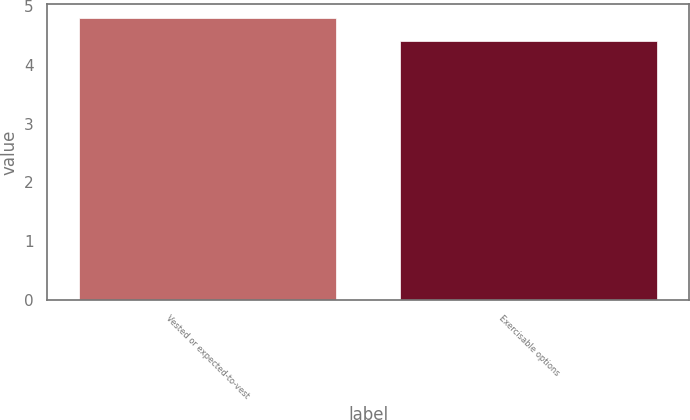<chart> <loc_0><loc_0><loc_500><loc_500><bar_chart><fcel>Vested or expected-to-vest<fcel>Exercisable options<nl><fcel>4.8<fcel>4.4<nl></chart> 